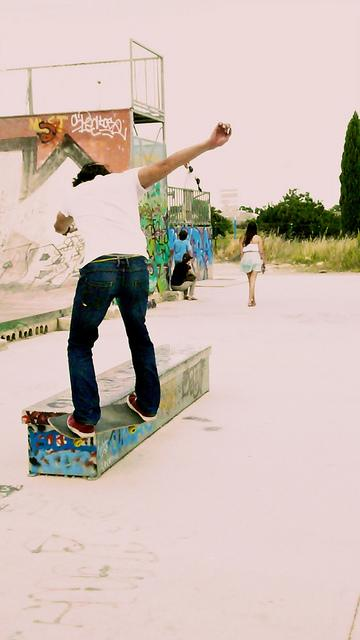Why si the board hanging from the box? Please explain your reasoning. showing off. The skateboarder is doing a trick. 